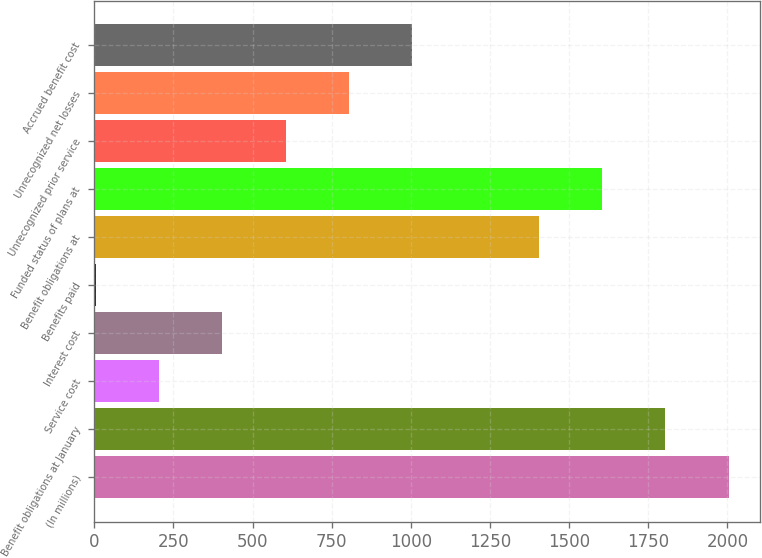<chart> <loc_0><loc_0><loc_500><loc_500><bar_chart><fcel>(In millions)<fcel>Benefit obligations at January<fcel>Service cost<fcel>Interest cost<fcel>Benefits paid<fcel>Benefit obligations at<fcel>Funded status of plans at<fcel>Unrecognized prior service<fcel>Unrecognized net losses<fcel>Accrued benefit cost<nl><fcel>2004<fcel>1804.1<fcel>204.9<fcel>404.8<fcel>5<fcel>1404.3<fcel>1604.2<fcel>604.7<fcel>804.6<fcel>1004.5<nl></chart> 